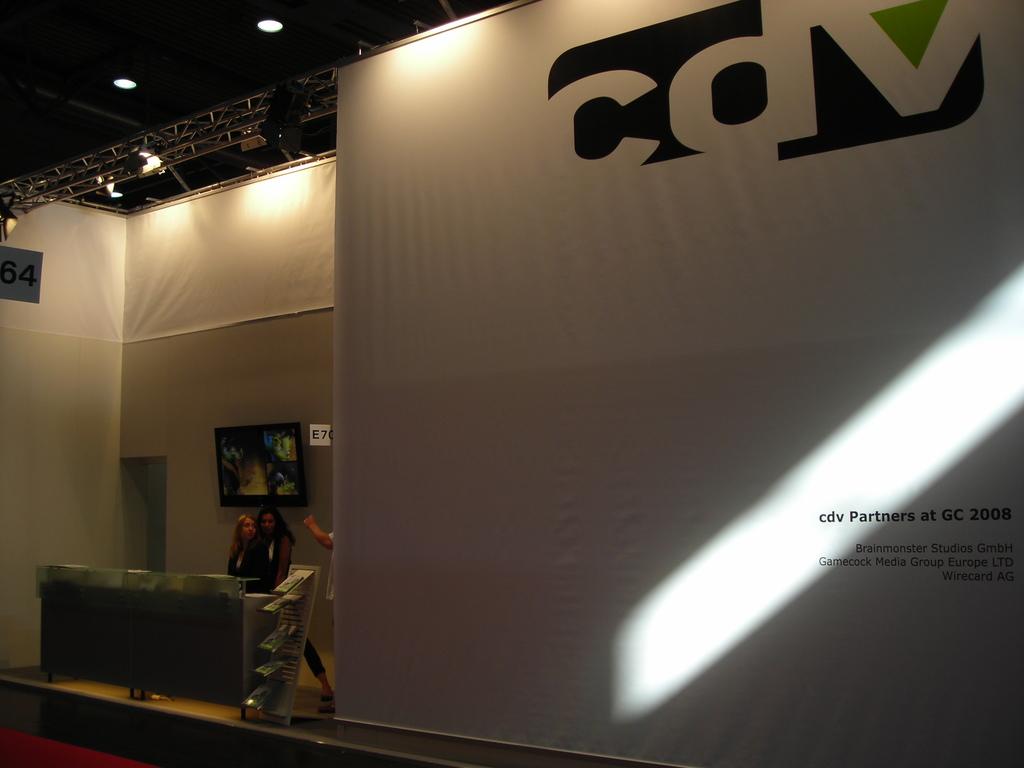What is the name of the partners?
Keep it short and to the point. Cdv. What year did this event take place?
Offer a very short reply. 2008. 